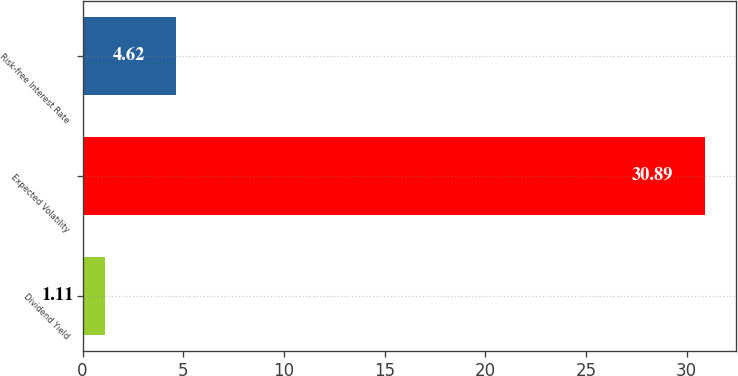Convert chart. <chart><loc_0><loc_0><loc_500><loc_500><bar_chart><fcel>Dividend Yield<fcel>Expected Volatility<fcel>Risk-free Interest Rate<nl><fcel>1.11<fcel>30.89<fcel>4.62<nl></chart> 